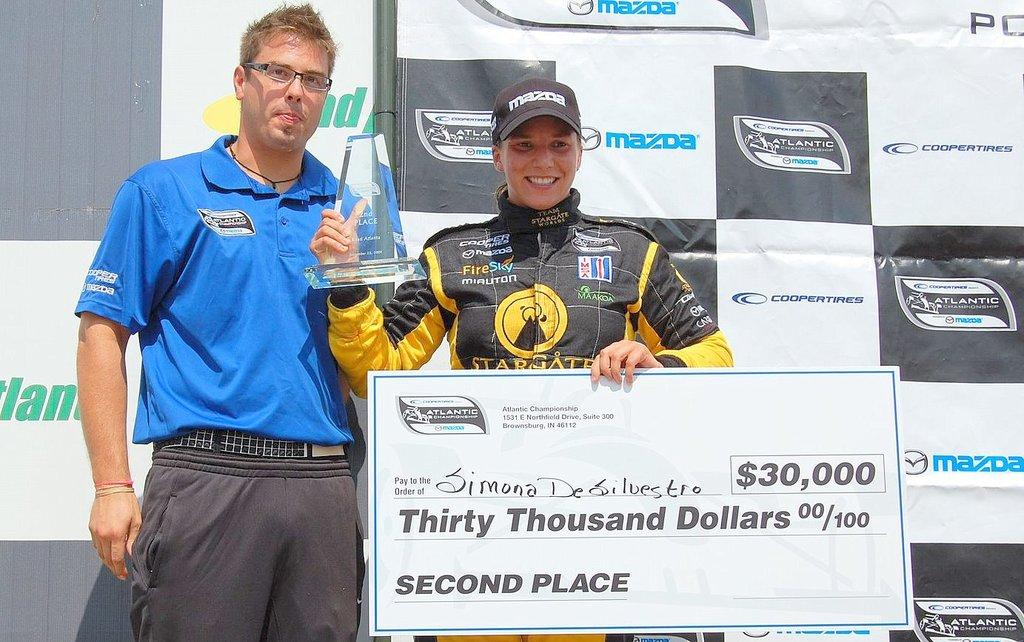Provide a one-sentence caption for the provided image. a man in a yellow and black jersey holding a check for $30,000 for second place. 